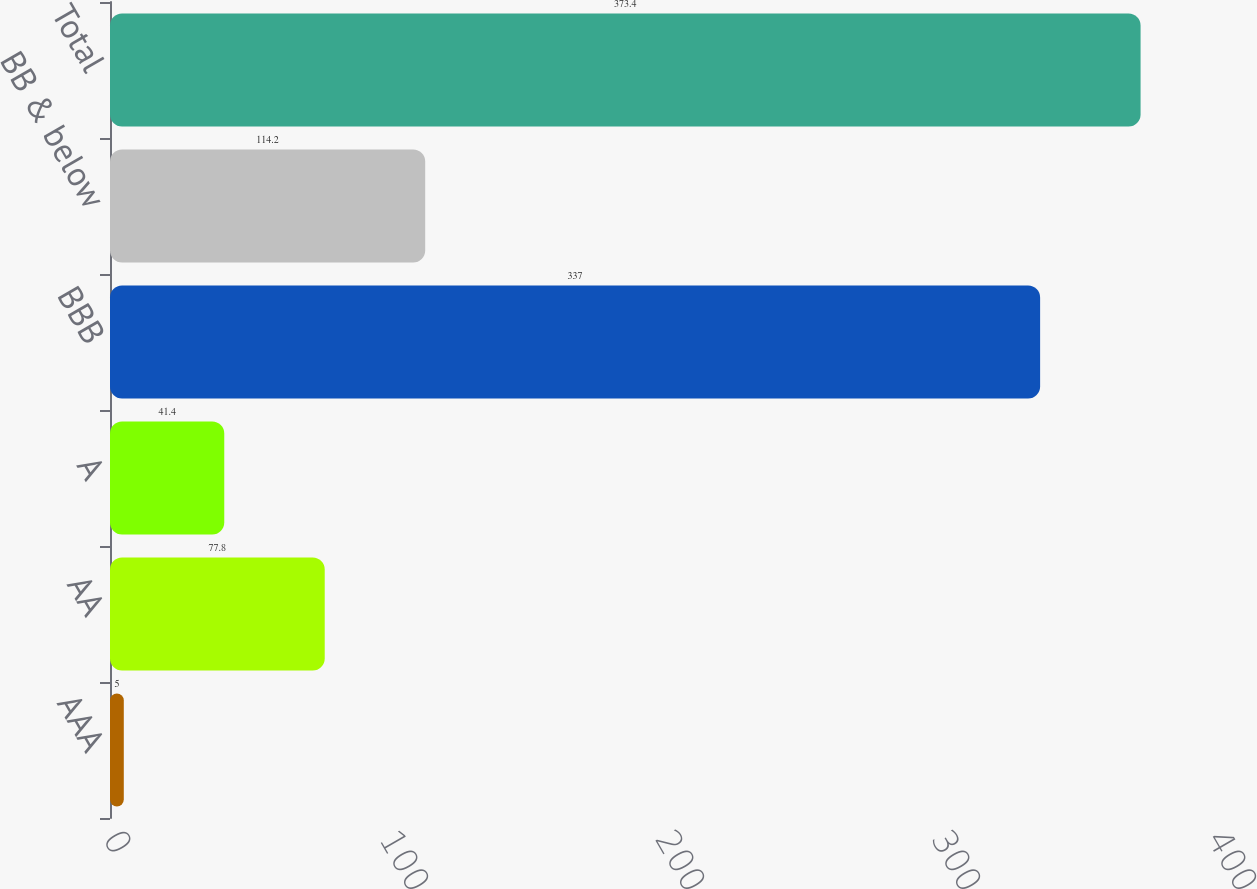<chart> <loc_0><loc_0><loc_500><loc_500><bar_chart><fcel>AAA<fcel>AA<fcel>A<fcel>BBB<fcel>BB & below<fcel>Total<nl><fcel>5<fcel>77.8<fcel>41.4<fcel>337<fcel>114.2<fcel>373.4<nl></chart> 